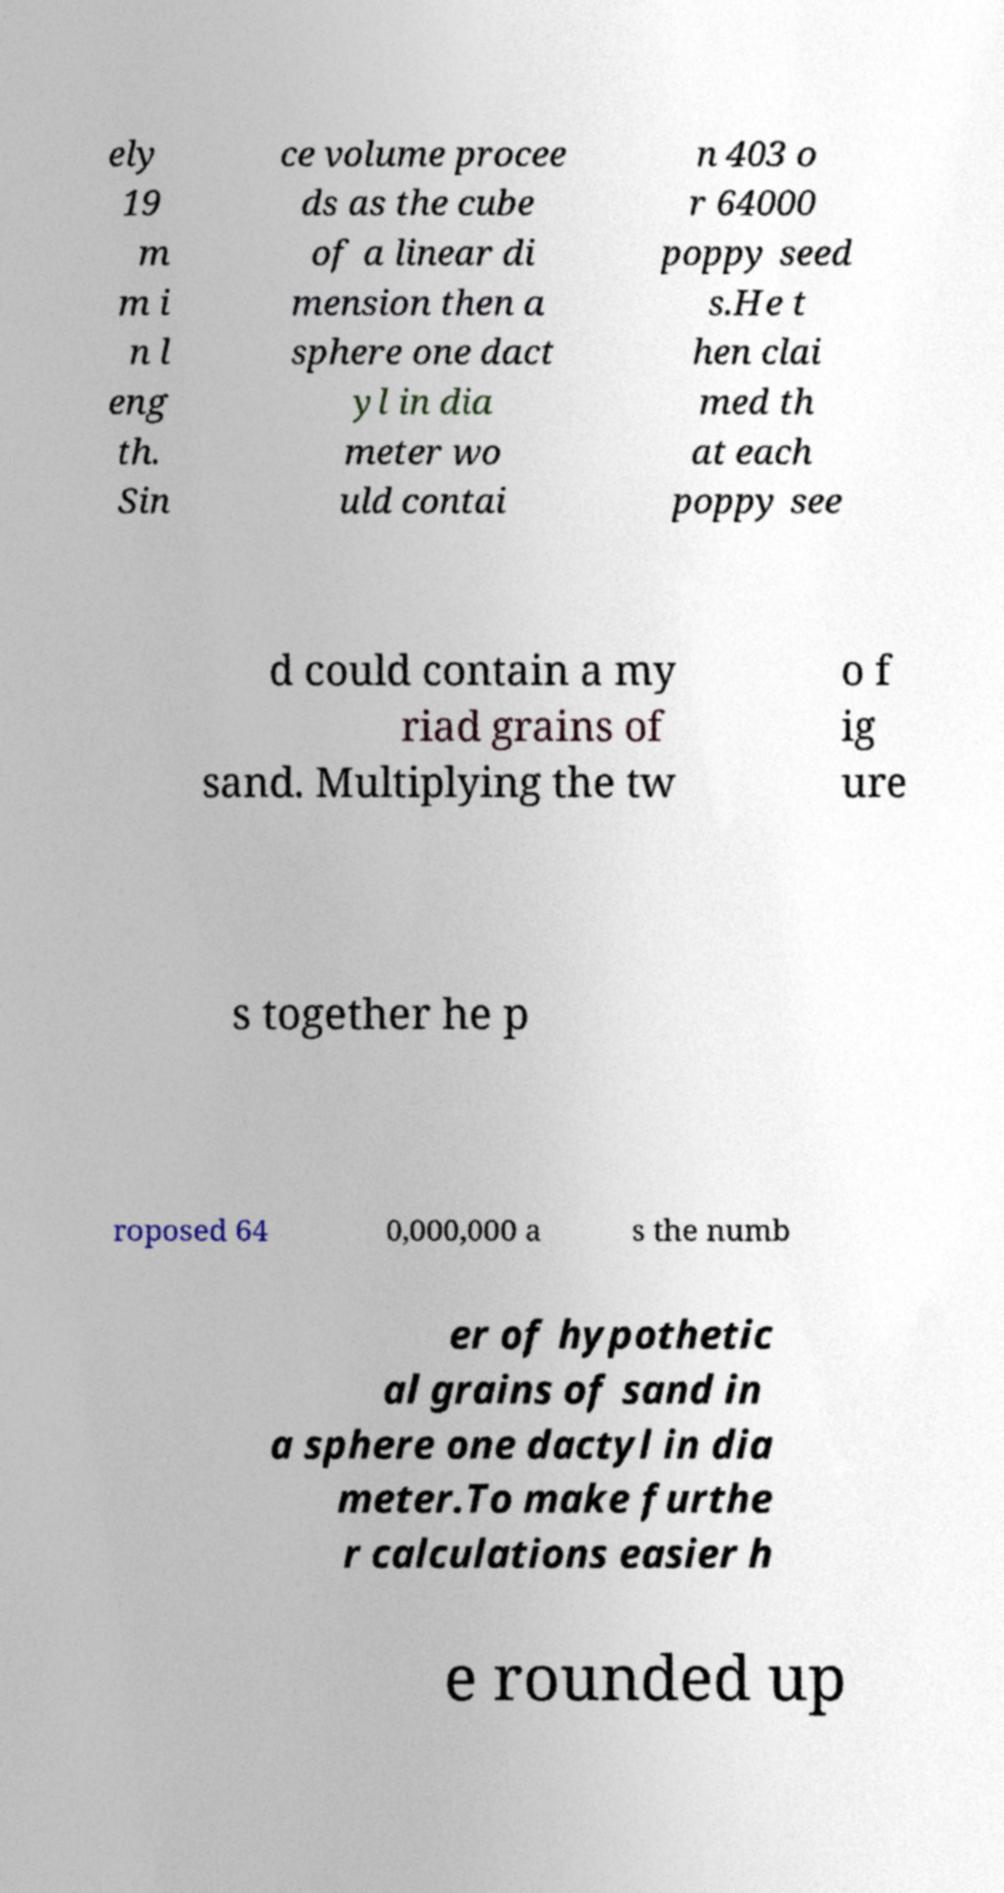For documentation purposes, I need the text within this image transcribed. Could you provide that? ely 19 m m i n l eng th. Sin ce volume procee ds as the cube of a linear di mension then a sphere one dact yl in dia meter wo uld contai n 403 o r 64000 poppy seed s.He t hen clai med th at each poppy see d could contain a my riad grains of sand. Multiplying the tw o f ig ure s together he p roposed 64 0,000,000 a s the numb er of hypothetic al grains of sand in a sphere one dactyl in dia meter.To make furthe r calculations easier h e rounded up 